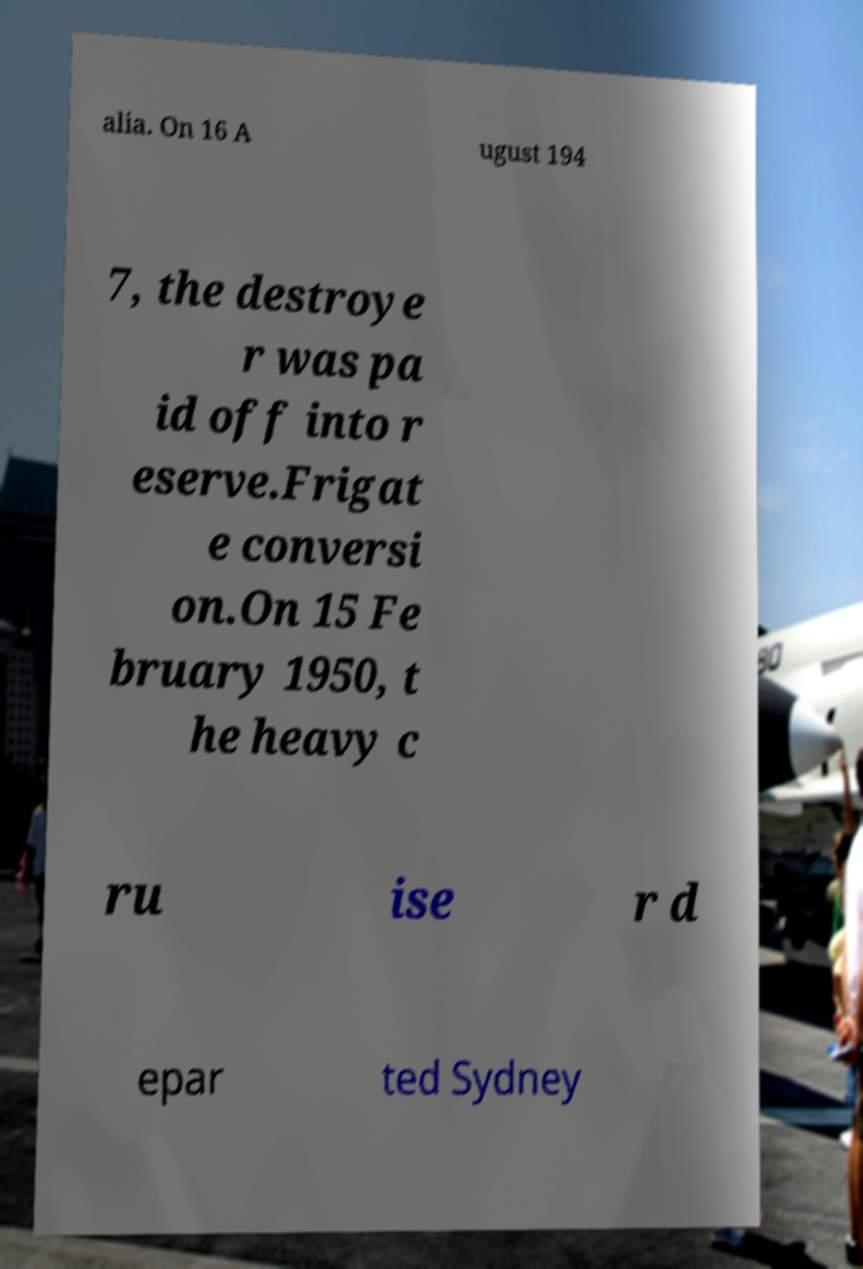There's text embedded in this image that I need extracted. Can you transcribe it verbatim? alia. On 16 A ugust 194 7, the destroye r was pa id off into r eserve.Frigat e conversi on.On 15 Fe bruary 1950, t he heavy c ru ise r d epar ted Sydney 